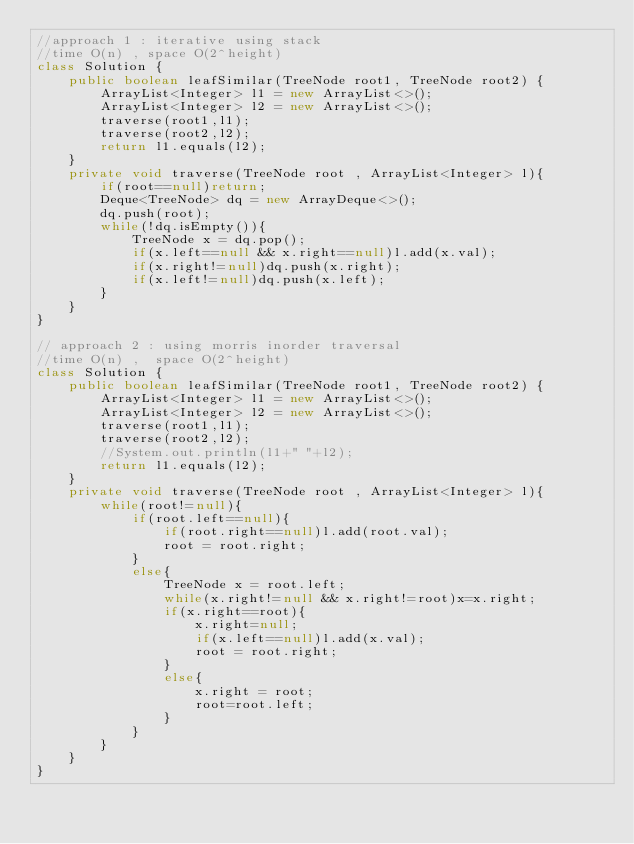<code> <loc_0><loc_0><loc_500><loc_500><_Java_>//approach 1 : iterative using stack
//time O(n) , space O(2^height)
class Solution {
    public boolean leafSimilar(TreeNode root1, TreeNode root2) {
        ArrayList<Integer> l1 = new ArrayList<>();
        ArrayList<Integer> l2 = new ArrayList<>();
        traverse(root1,l1);
        traverse(root2,l2);
        return l1.equals(l2);
    }
    private void traverse(TreeNode root , ArrayList<Integer> l){
        if(root==null)return;
        Deque<TreeNode> dq = new ArrayDeque<>();
        dq.push(root);
        while(!dq.isEmpty()){
            TreeNode x = dq.pop();
            if(x.left==null && x.right==null)l.add(x.val);
            if(x.right!=null)dq.push(x.right);
            if(x.left!=null)dq.push(x.left);
        }
    }
}

// approach 2 : using morris inorder traversal
//time O(n) ,  space O(2^height)
class Solution {
    public boolean leafSimilar(TreeNode root1, TreeNode root2) {
        ArrayList<Integer> l1 = new ArrayList<>();
        ArrayList<Integer> l2 = new ArrayList<>();
        traverse(root1,l1);
        traverse(root2,l2);
        //System.out.println(l1+" "+l2);
        return l1.equals(l2);
    }
    private void traverse(TreeNode root , ArrayList<Integer> l){
        while(root!=null){
            if(root.left==null){
                if(root.right==null)l.add(root.val);
                root = root.right;
            }
            else{
                TreeNode x = root.left;
                while(x.right!=null && x.right!=root)x=x.right;
                if(x.right==root){
                    x.right=null;
                    if(x.left==null)l.add(x.val);
                    root = root.right;
                }
                else{
                    x.right = root;
                    root=root.left;
                }
            }
        }
    }
}
</code> 